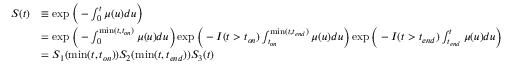Convert formula to latex. <formula><loc_0><loc_0><loc_500><loc_500>\begin{array} { r l } { S ( t ) } & { \equiv \exp { \left ( - \int _ { 0 } ^ { t } \mu ( u ) d u \right ) } } \\ & { = \exp { \left ( - \int _ { 0 } ^ { \min ( t , t _ { o n } ) } \mu ( u ) d u \right ) } \exp { \left ( - I ( t > t _ { o n } ) \int _ { t _ { o n } } ^ { \min ( t , t _ { e n d } ) } \mu ( u ) d u \right ) } \exp { \left ( - I ( t > t _ { e n d } ) \int _ { t _ { e n d } } ^ { t } \mu ( u ) d u \right ) } } \\ & { = S _ { 1 } ( \min ( t , t _ { o n } ) ) S _ { 2 } ( \min ( t , t _ { e n d } ) ) S _ { 3 } ( t ) } \end{array}</formula> 